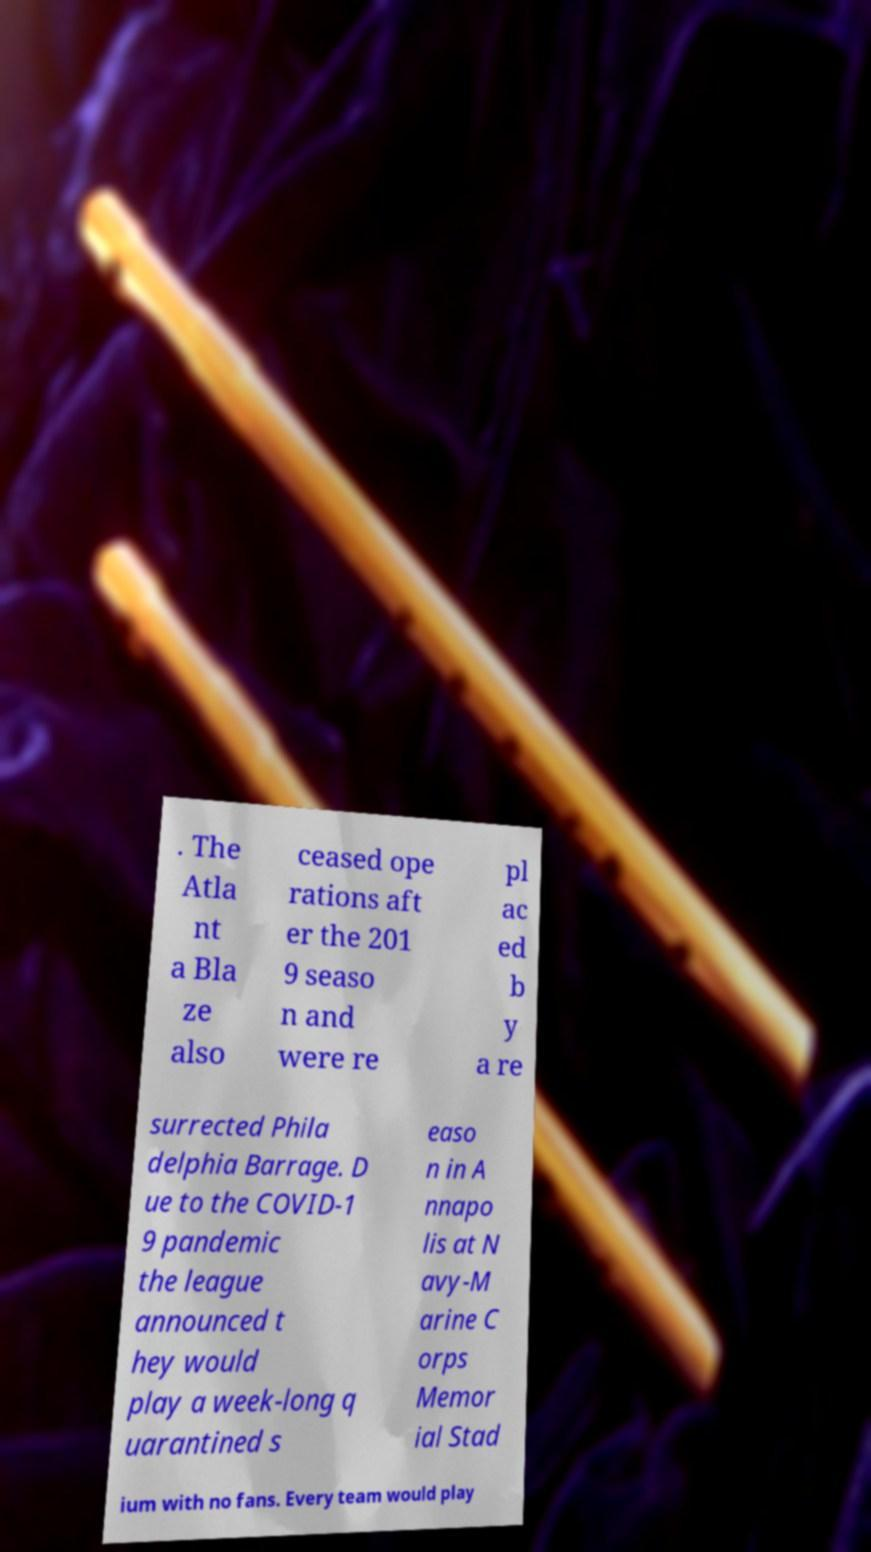Can you accurately transcribe the text from the provided image for me? . The Atla nt a Bla ze also ceased ope rations aft er the 201 9 seaso n and were re pl ac ed b y a re surrected Phila delphia Barrage. D ue to the COVID-1 9 pandemic the league announced t hey would play a week-long q uarantined s easo n in A nnapo lis at N avy-M arine C orps Memor ial Stad ium with no fans. Every team would play 